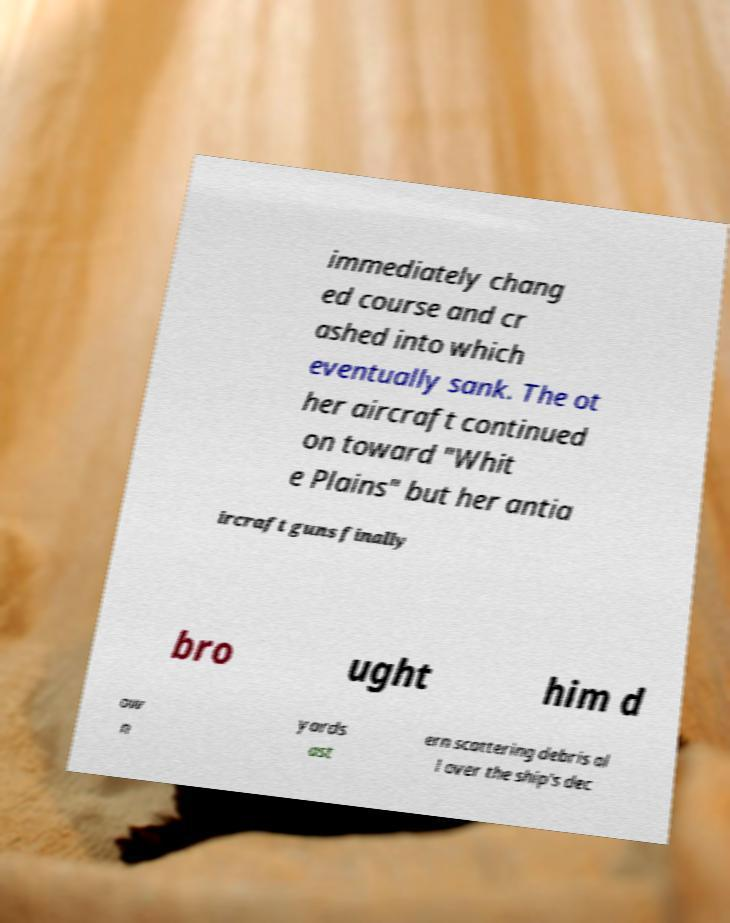Please identify and transcribe the text found in this image. immediately chang ed course and cr ashed into which eventually sank. The ot her aircraft continued on toward "Whit e Plains" but her antia ircraft guns finally bro ught him d ow n yards ast ern scattering debris al l over the ship's dec 